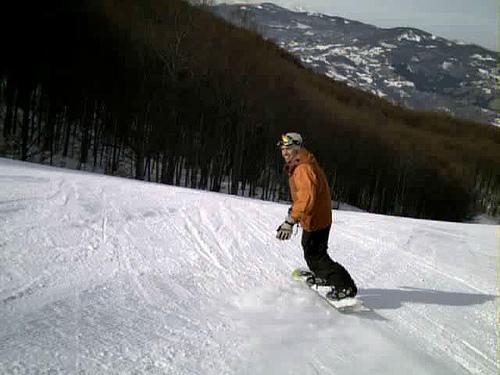How many people in the photo?
Give a very brief answer. 1. 